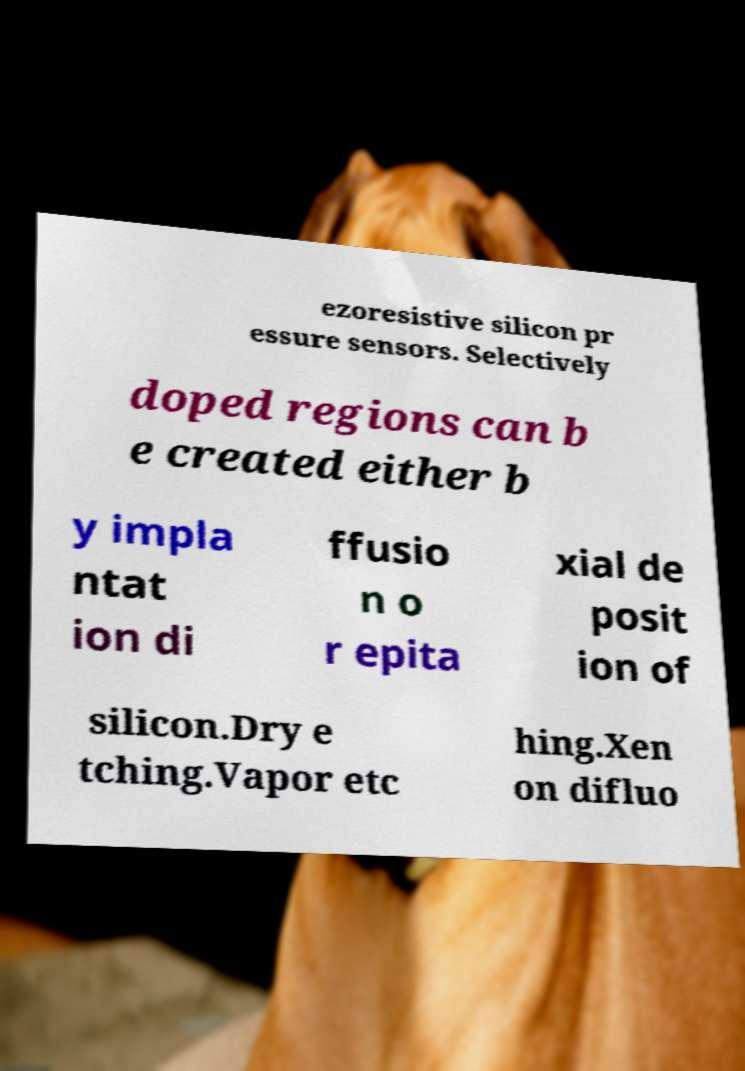Could you extract and type out the text from this image? ezoresistive silicon pr essure sensors. Selectively doped regions can b e created either b y impla ntat ion di ffusio n o r epita xial de posit ion of silicon.Dry e tching.Vapor etc hing.Xen on difluo 